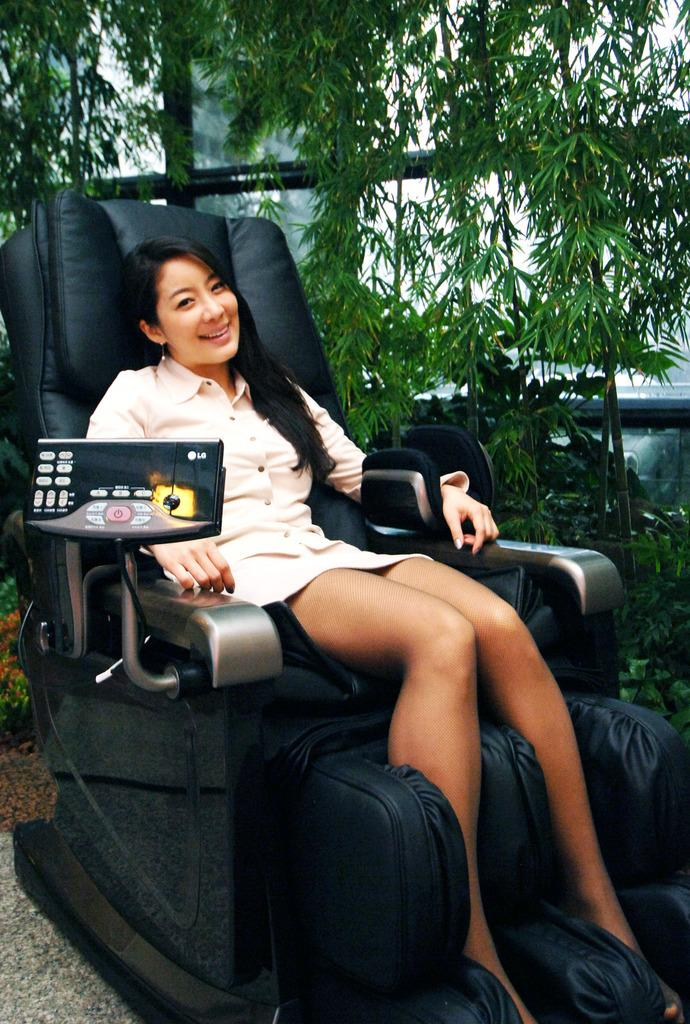Who is the main subject in the image? There is a woman in the image. What is the woman doing in the image? The woman is sitting on a chair and smiling. What can be seen in the background of the image? There are plants in the background of the image. What month is the protest taking place in the image? There is no protest present in the image, so it is not possible to determine the month. 